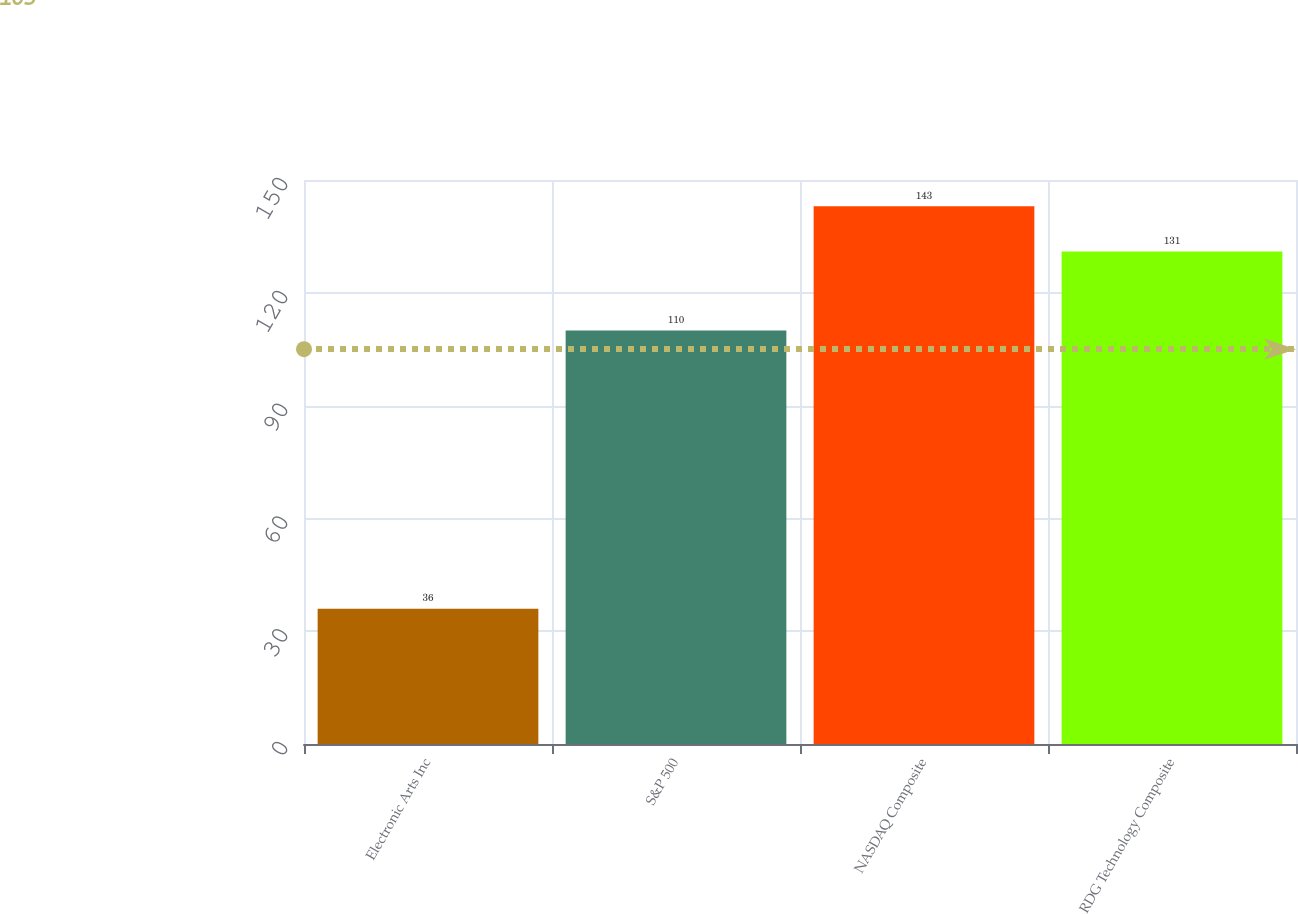Convert chart. <chart><loc_0><loc_0><loc_500><loc_500><bar_chart><fcel>Electronic Arts Inc<fcel>S&P 500<fcel>NASDAQ Composite<fcel>RDG Technology Composite<nl><fcel>36<fcel>110<fcel>143<fcel>131<nl></chart> 